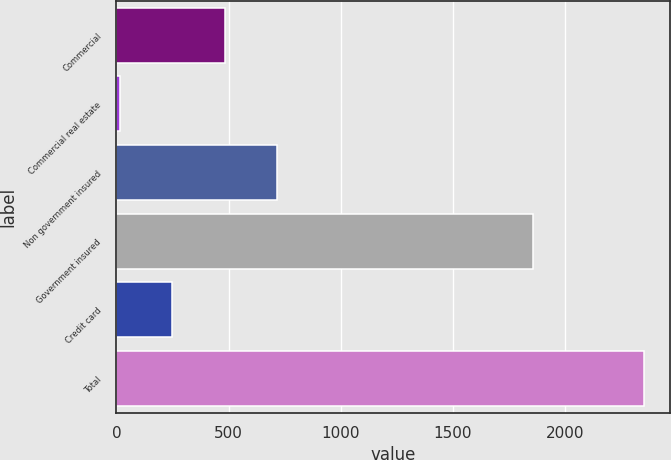Convert chart to OTSL. <chart><loc_0><loc_0><loc_500><loc_500><bar_chart><fcel>Commercial<fcel>Commercial real estate<fcel>Non government insured<fcel>Government insured<fcel>Credit card<fcel>Total<nl><fcel>482.2<fcel>15<fcel>715.8<fcel>1855<fcel>248.6<fcel>2351<nl></chart> 